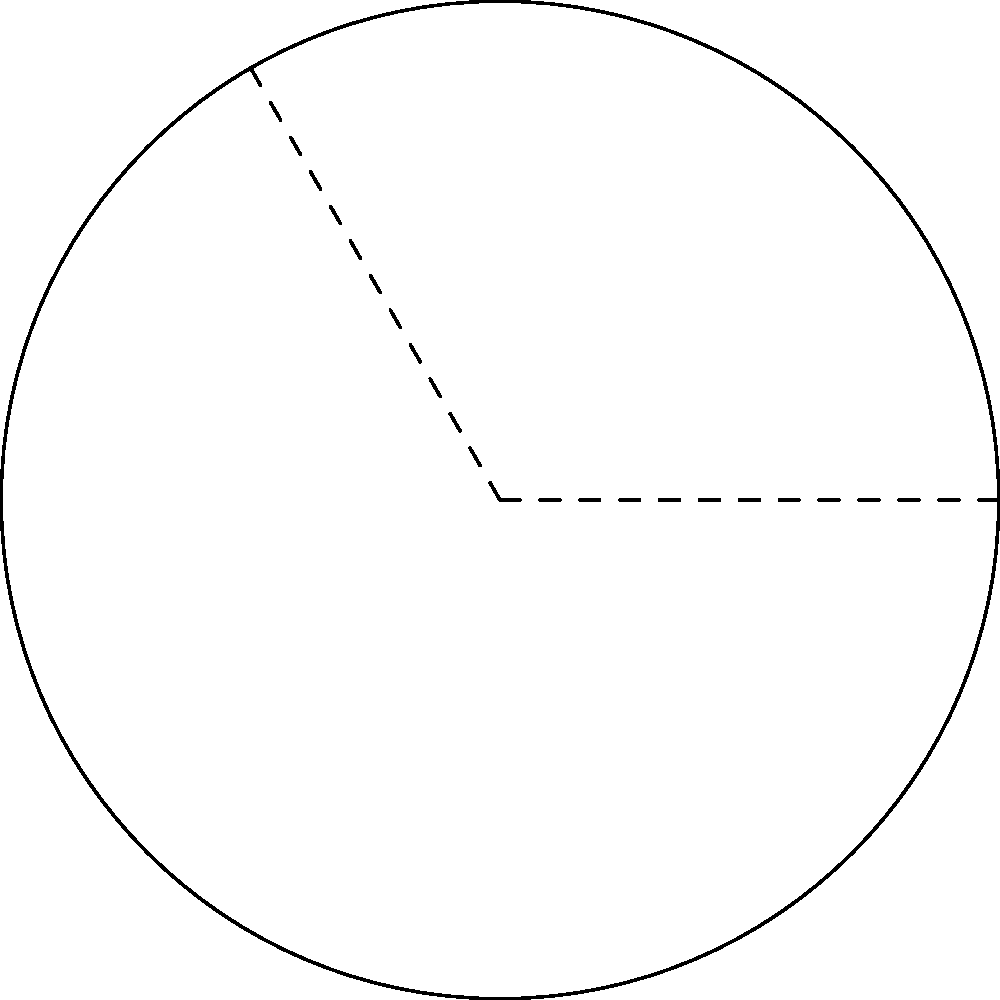You're designing a curved running track for a new sports complex in Nairobi. The track forms part of a circle with radius 60 meters. If the central angle of the track is 120°, what is the length of the curved part of the track to the nearest meter? To solve this problem, we'll use the formula for arc length:

Arc length = $\frac{\theta}{360°} \cdot 2\pi r$

Where:
$\theta$ = central angle in degrees
$r$ = radius of the circle

Given:
- Radius $(r) = 60$ meters
- Central angle $(\theta) = 120°$

Step 1: Substitute the values into the formula
Arc length = $\frac{120°}{360°} \cdot 2\pi \cdot 60$

Step 2: Simplify the fraction
Arc length = $\frac{1}{3} \cdot 2\pi \cdot 60$

Step 3: Calculate $2\pi$
Arc length = $\frac{1}{3} \cdot 6.28318 \cdot 60$

Step 4: Multiply
Arc length = $125.66$ meters

Step 5: Round to the nearest meter
Arc length ≈ 126 meters
Answer: 126 meters 